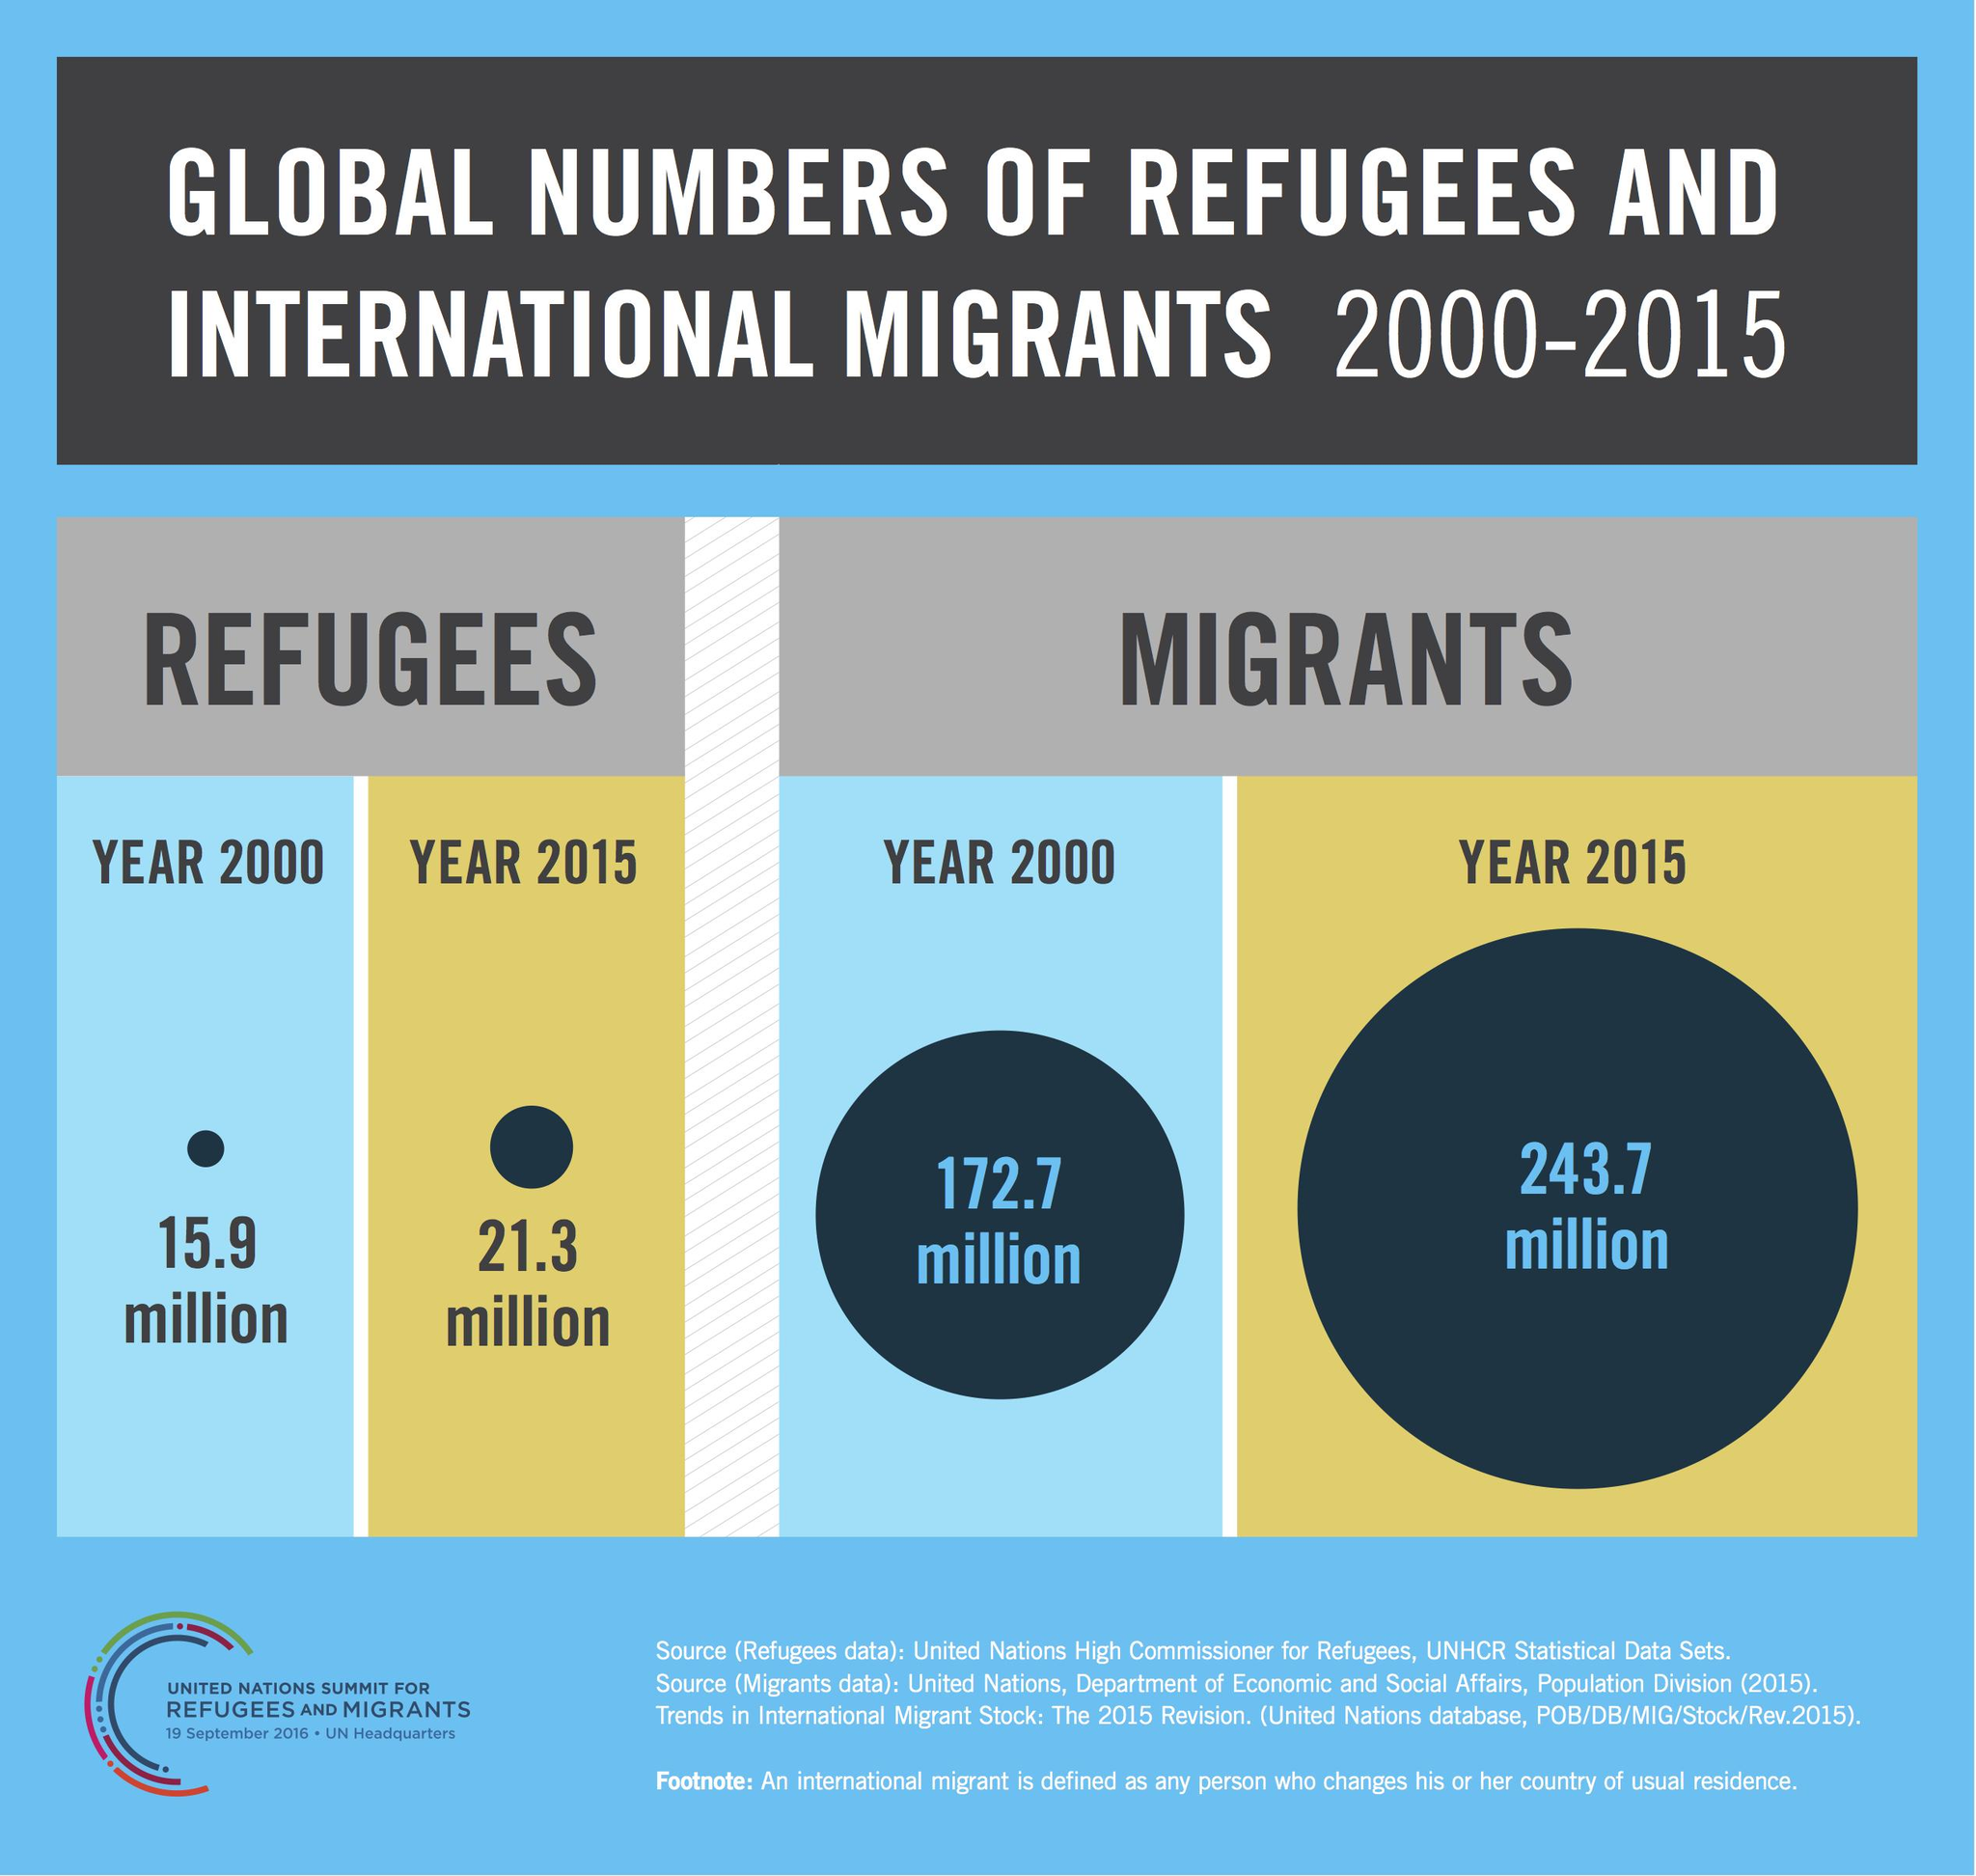Point out several critical features in this image. In the year 2015, there was a significant increase in the number of refugees compared to the year 2000, with a net increase of 5.4 million refugees. In the year 2015, there was a significant increase in the number of migrants compared to the year 2000, with a total of 71 million additional migrants. 